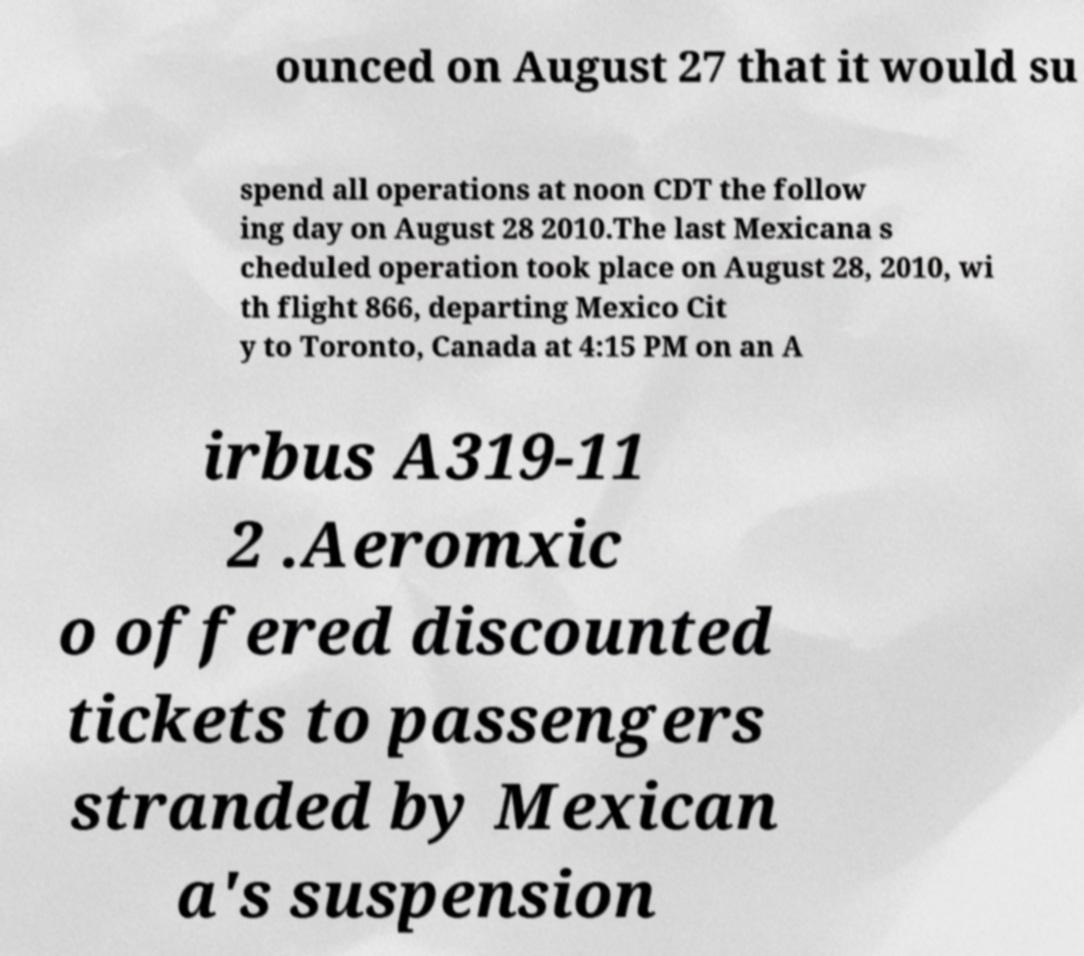Could you extract and type out the text from this image? ounced on August 27 that it would su spend all operations at noon CDT the follow ing day on August 28 2010.The last Mexicana s cheduled operation took place on August 28, 2010, wi th flight 866, departing Mexico Cit y to Toronto, Canada at 4:15 PM on an A irbus A319-11 2 .Aeromxic o offered discounted tickets to passengers stranded by Mexican a's suspension 